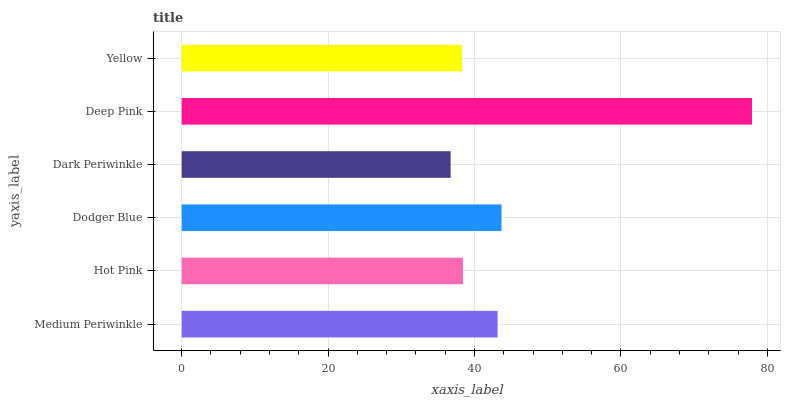Is Dark Periwinkle the minimum?
Answer yes or no. Yes. Is Deep Pink the maximum?
Answer yes or no. Yes. Is Hot Pink the minimum?
Answer yes or no. No. Is Hot Pink the maximum?
Answer yes or no. No. Is Medium Periwinkle greater than Hot Pink?
Answer yes or no. Yes. Is Hot Pink less than Medium Periwinkle?
Answer yes or no. Yes. Is Hot Pink greater than Medium Periwinkle?
Answer yes or no. No. Is Medium Periwinkle less than Hot Pink?
Answer yes or no. No. Is Medium Periwinkle the high median?
Answer yes or no. Yes. Is Hot Pink the low median?
Answer yes or no. Yes. Is Yellow the high median?
Answer yes or no. No. Is Deep Pink the low median?
Answer yes or no. No. 